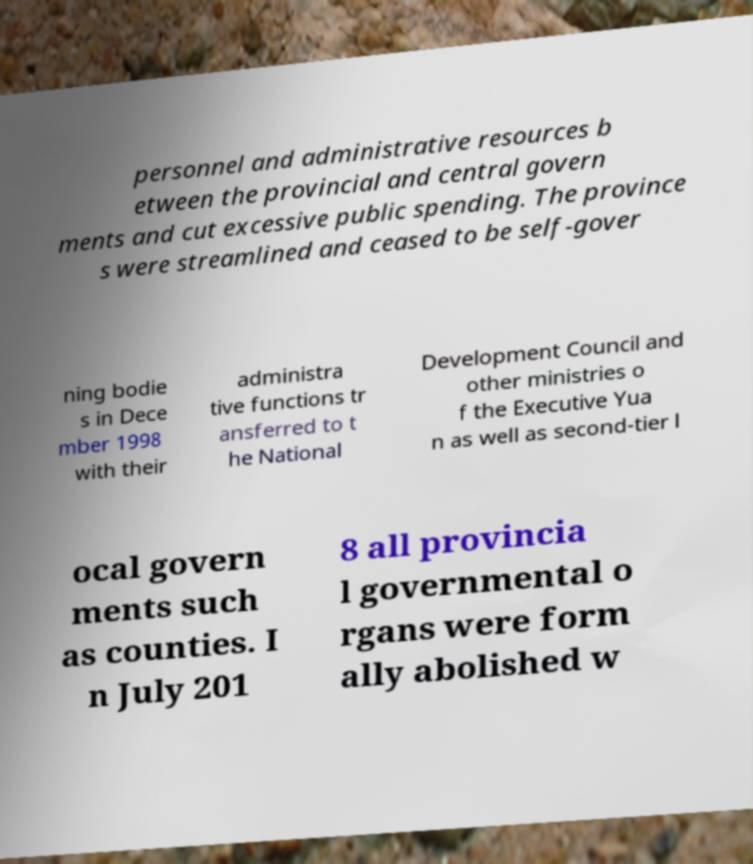I need the written content from this picture converted into text. Can you do that? personnel and administrative resources b etween the provincial and central govern ments and cut excessive public spending. The province s were streamlined and ceased to be self-gover ning bodie s in Dece mber 1998 with their administra tive functions tr ansferred to t he National Development Council and other ministries o f the Executive Yua n as well as second-tier l ocal govern ments such as counties. I n July 201 8 all provincia l governmental o rgans were form ally abolished w 